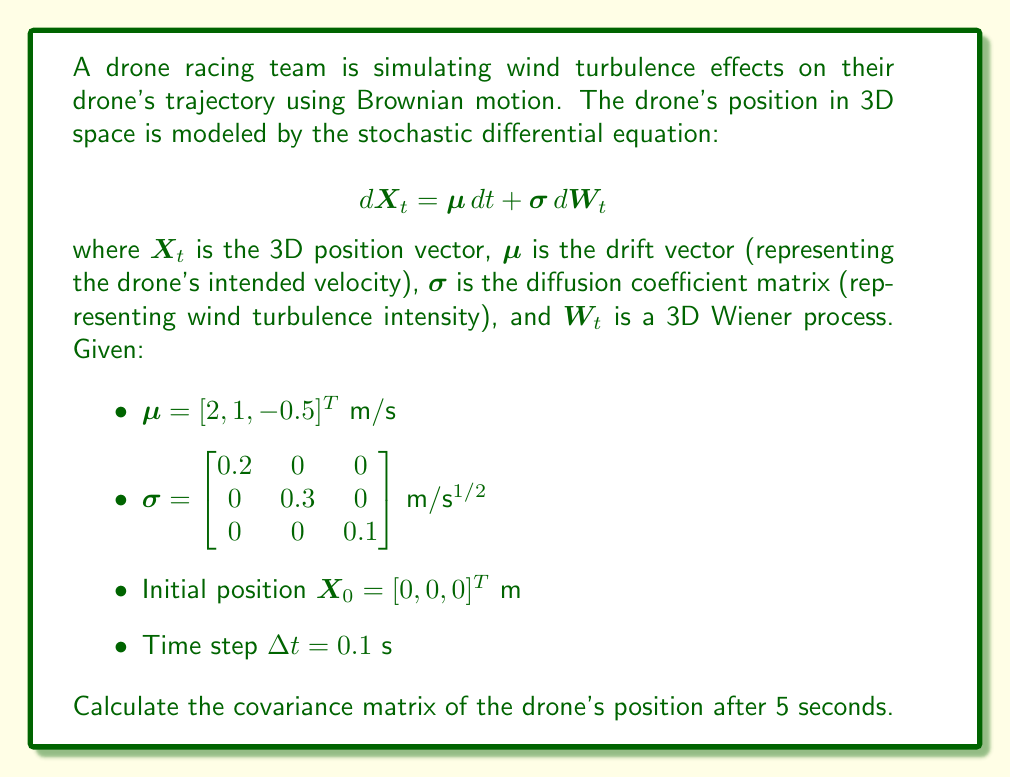Can you solve this math problem? To solve this problem, we'll follow these steps:

1) Recall that for a multidimensional Brownian motion with drift, the covariance matrix after time $t$ is given by:

   $$Cov(X_t) = t \sigma \sigma^T$$

2) We need to calculate this for $t = 5$ seconds.

3) First, let's calculate $\sigma \sigma^T$:

   $$\sigma \sigma^T = \begin{bmatrix} 0.2 & 0 & 0 \\ 0 & 0.3 & 0 \\ 0 & 0 & 0.1 \end{bmatrix} \begin{bmatrix} 0.2 & 0 & 0 \\ 0 & 0.3 & 0 \\ 0 & 0 & 0.1 \end{bmatrix}^T$$

   $$= \begin{bmatrix} 0.2 & 0 & 0 \\ 0 & 0.3 & 0 \\ 0 & 0 & 0.1 \end{bmatrix} \begin{bmatrix} 0.2 & 0 & 0 \\ 0 & 0.3 & 0 \\ 0 & 0 & 0.1 \end{bmatrix}$$

   $$= \begin{bmatrix} 0.04 & 0 & 0 \\ 0 & 0.09 & 0 \\ 0 & 0 & 0.01 \end{bmatrix}$$

4) Now, we multiply this by $t = 5$:

   $$Cov(X_5) = 5 \begin{bmatrix} 0.04 & 0 & 0 \\ 0 & 0.09 & 0 \\ 0 & 0 & 0.01 \end{bmatrix}$$

   $$= \begin{bmatrix} 0.2 & 0 & 0 \\ 0 & 0.45 & 0 \\ 0 & 0 & 0.05 \end{bmatrix}$$

5) This gives us the covariance matrix in m^2.

Note: The drift $\mu$ doesn't affect the covariance, it only affects the mean position.
Answer: $$\begin{bmatrix} 0.2 & 0 & 0 \\ 0 & 0.45 & 0 \\ 0 & 0 & 0.05 \end{bmatrix}$$ m^2 